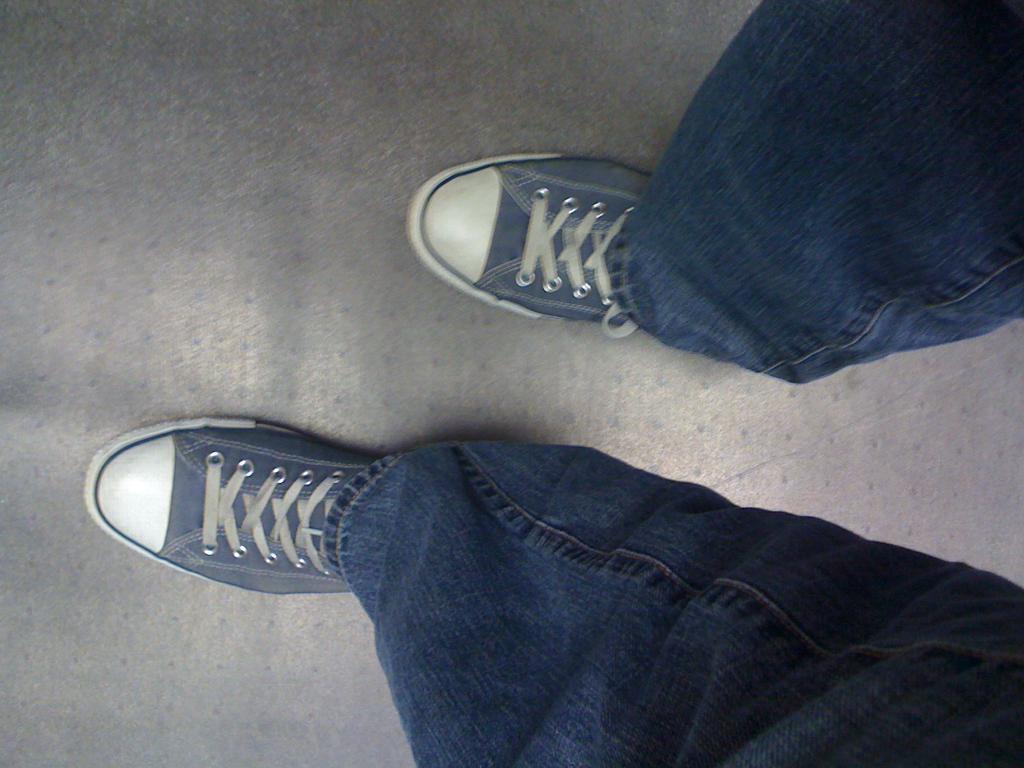Could you give a brief overview of what you see in this image? In this image I can see a person's legs wearing shoes, jeans and standing on the floor. 